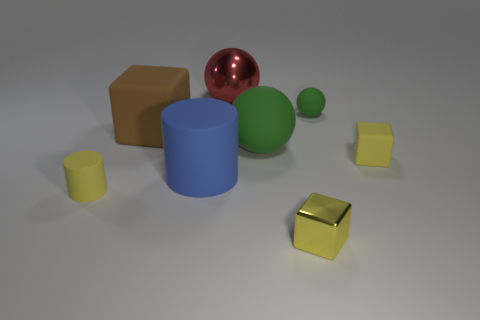Subtract all green blocks. How many green balls are left? 2 Subtract all large green rubber spheres. How many spheres are left? 2 Add 1 tiny gray matte cylinders. How many objects exist? 9 Subtract all spheres. How many objects are left? 5 Subtract 0 blue spheres. How many objects are left? 8 Subtract all green cylinders. Subtract all purple cubes. How many cylinders are left? 2 Subtract all brown matte cubes. Subtract all rubber balls. How many objects are left? 5 Add 5 big blue rubber cylinders. How many big blue rubber cylinders are left? 6 Add 1 big cyan rubber spheres. How many big cyan rubber spheres exist? 1 